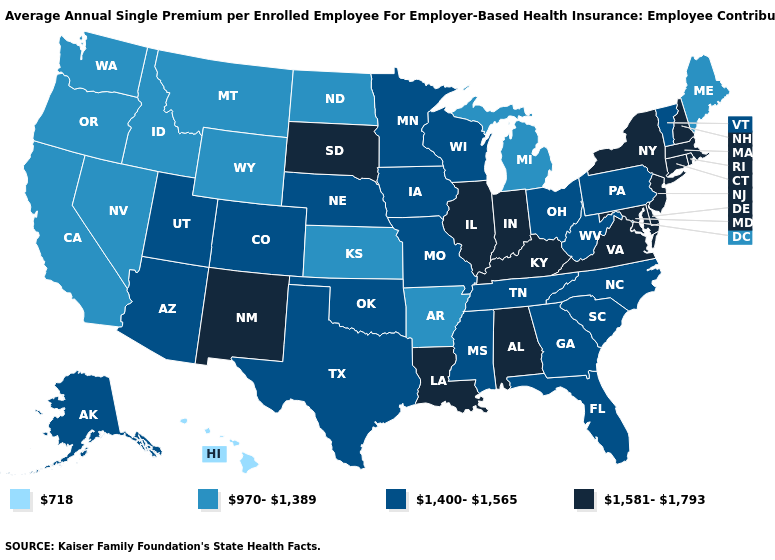What is the value of Ohio?
Give a very brief answer. 1,400-1,565. Does the first symbol in the legend represent the smallest category?
Short answer required. Yes. Among the states that border Kansas , which have the highest value?
Keep it brief. Colorado, Missouri, Nebraska, Oklahoma. What is the highest value in the Northeast ?
Write a very short answer. 1,581-1,793. Does Colorado have the lowest value in the USA?
Short answer required. No. Which states have the highest value in the USA?
Keep it brief. Alabama, Connecticut, Delaware, Illinois, Indiana, Kentucky, Louisiana, Maryland, Massachusetts, New Hampshire, New Jersey, New Mexico, New York, Rhode Island, South Dakota, Virginia. Which states have the lowest value in the USA?
Write a very short answer. Hawaii. What is the value of New Jersey?
Concise answer only. 1,581-1,793. Does Virginia have a higher value than Nebraska?
Write a very short answer. Yes. Does the map have missing data?
Keep it brief. No. Name the states that have a value in the range 718?
Short answer required. Hawaii. Which states hav the highest value in the South?
Be succinct. Alabama, Delaware, Kentucky, Louisiana, Maryland, Virginia. What is the value of Washington?
Short answer required. 970-1,389. What is the lowest value in the South?
Keep it brief. 970-1,389. How many symbols are there in the legend?
Be succinct. 4. 